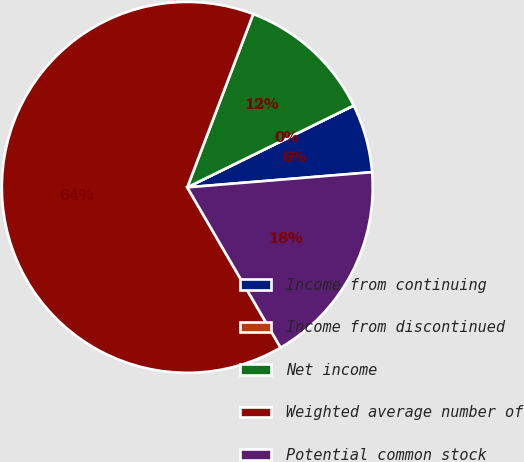Convert chart to OTSL. <chart><loc_0><loc_0><loc_500><loc_500><pie_chart><fcel>Income from continuing<fcel>Income from discontinued<fcel>Net income<fcel>Weighted average number of<fcel>Potential common stock<nl><fcel>5.97%<fcel>0.0%<fcel>11.94%<fcel>64.18%<fcel>17.91%<nl></chart> 